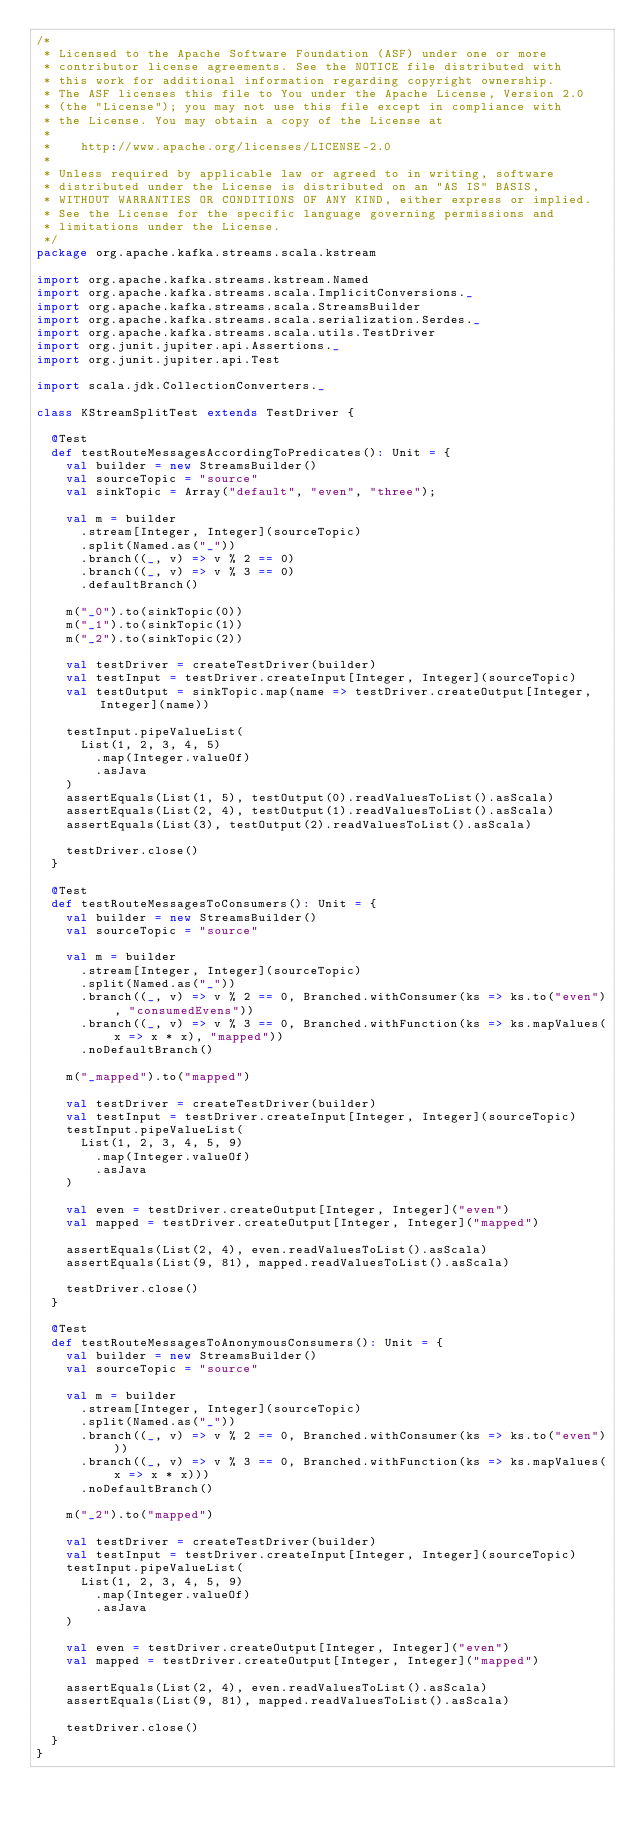Convert code to text. <code><loc_0><loc_0><loc_500><loc_500><_Scala_>/*
 * Licensed to the Apache Software Foundation (ASF) under one or more
 * contributor license agreements. See the NOTICE file distributed with
 * this work for additional information regarding copyright ownership.
 * The ASF licenses this file to You under the Apache License, Version 2.0
 * (the "License"); you may not use this file except in compliance with
 * the License. You may obtain a copy of the License at
 *
 *    http://www.apache.org/licenses/LICENSE-2.0
 *
 * Unless required by applicable law or agreed to in writing, software
 * distributed under the License is distributed on an "AS IS" BASIS,
 * WITHOUT WARRANTIES OR CONDITIONS OF ANY KIND, either express or implied.
 * See the License for the specific language governing permissions and
 * limitations under the License.
 */
package org.apache.kafka.streams.scala.kstream

import org.apache.kafka.streams.kstream.Named
import org.apache.kafka.streams.scala.ImplicitConversions._
import org.apache.kafka.streams.scala.StreamsBuilder
import org.apache.kafka.streams.scala.serialization.Serdes._
import org.apache.kafka.streams.scala.utils.TestDriver
import org.junit.jupiter.api.Assertions._
import org.junit.jupiter.api.Test

import scala.jdk.CollectionConverters._

class KStreamSplitTest extends TestDriver {

  @Test
  def testRouteMessagesAccordingToPredicates(): Unit = {
    val builder = new StreamsBuilder()
    val sourceTopic = "source"
    val sinkTopic = Array("default", "even", "three");

    val m = builder
      .stream[Integer, Integer](sourceTopic)
      .split(Named.as("_"))
      .branch((_, v) => v % 2 == 0)
      .branch((_, v) => v % 3 == 0)
      .defaultBranch()

    m("_0").to(sinkTopic(0))
    m("_1").to(sinkTopic(1))
    m("_2").to(sinkTopic(2))

    val testDriver = createTestDriver(builder)
    val testInput = testDriver.createInput[Integer, Integer](sourceTopic)
    val testOutput = sinkTopic.map(name => testDriver.createOutput[Integer, Integer](name))

    testInput.pipeValueList(
      List(1, 2, 3, 4, 5)
        .map(Integer.valueOf)
        .asJava
    )
    assertEquals(List(1, 5), testOutput(0).readValuesToList().asScala)
    assertEquals(List(2, 4), testOutput(1).readValuesToList().asScala)
    assertEquals(List(3), testOutput(2).readValuesToList().asScala)

    testDriver.close()
  }

  @Test
  def testRouteMessagesToConsumers(): Unit = {
    val builder = new StreamsBuilder()
    val sourceTopic = "source"

    val m = builder
      .stream[Integer, Integer](sourceTopic)
      .split(Named.as("_"))
      .branch((_, v) => v % 2 == 0, Branched.withConsumer(ks => ks.to("even"), "consumedEvens"))
      .branch((_, v) => v % 3 == 0, Branched.withFunction(ks => ks.mapValues(x => x * x), "mapped"))
      .noDefaultBranch()

    m("_mapped").to("mapped")

    val testDriver = createTestDriver(builder)
    val testInput = testDriver.createInput[Integer, Integer](sourceTopic)
    testInput.pipeValueList(
      List(1, 2, 3, 4, 5, 9)
        .map(Integer.valueOf)
        .asJava
    )

    val even = testDriver.createOutput[Integer, Integer]("even")
    val mapped = testDriver.createOutput[Integer, Integer]("mapped")

    assertEquals(List(2, 4), even.readValuesToList().asScala)
    assertEquals(List(9, 81), mapped.readValuesToList().asScala)

    testDriver.close()
  }

  @Test
  def testRouteMessagesToAnonymousConsumers(): Unit = {
    val builder = new StreamsBuilder()
    val sourceTopic = "source"

    val m = builder
      .stream[Integer, Integer](sourceTopic)
      .split(Named.as("_"))
      .branch((_, v) => v % 2 == 0, Branched.withConsumer(ks => ks.to("even")))
      .branch((_, v) => v % 3 == 0, Branched.withFunction(ks => ks.mapValues(x => x * x)))
      .noDefaultBranch()

    m("_2").to("mapped")

    val testDriver = createTestDriver(builder)
    val testInput = testDriver.createInput[Integer, Integer](sourceTopic)
    testInput.pipeValueList(
      List(1, 2, 3, 4, 5, 9)
        .map(Integer.valueOf)
        .asJava
    )

    val even = testDriver.createOutput[Integer, Integer]("even")
    val mapped = testDriver.createOutput[Integer, Integer]("mapped")

    assertEquals(List(2, 4), even.readValuesToList().asScala)
    assertEquals(List(9, 81), mapped.readValuesToList().asScala)

    testDriver.close()
  }
}
</code> 